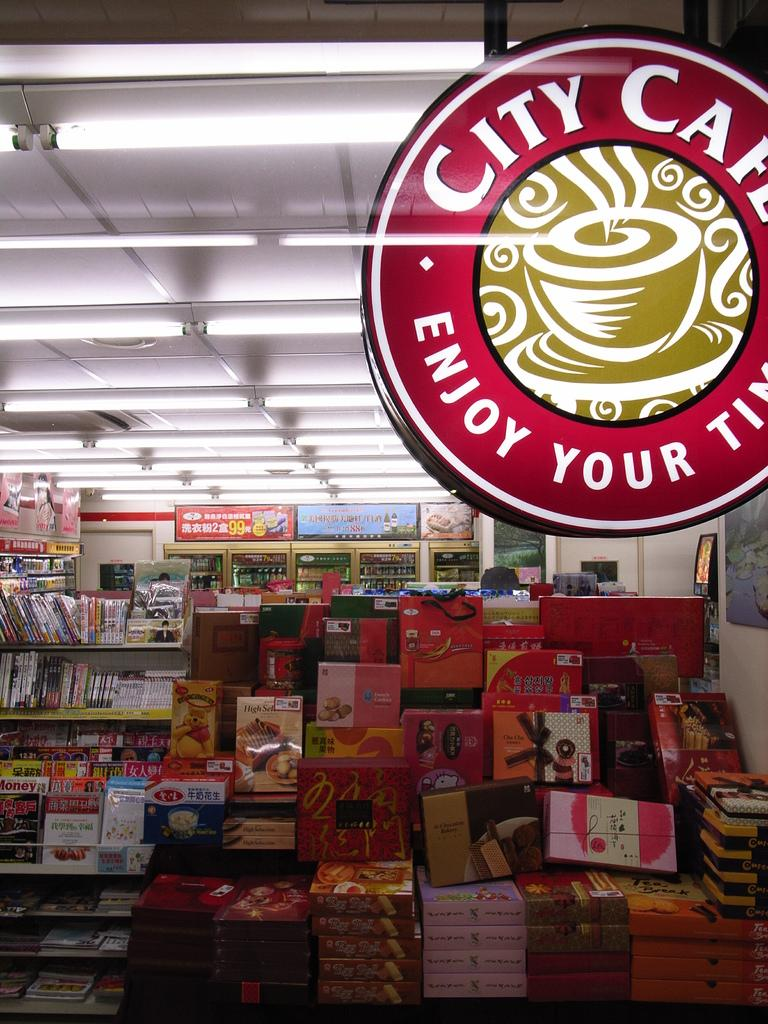<image>
Give a short and clear explanation of the subsequent image. City Cafe offers a variety of books, magazines, and snacks among other things. 